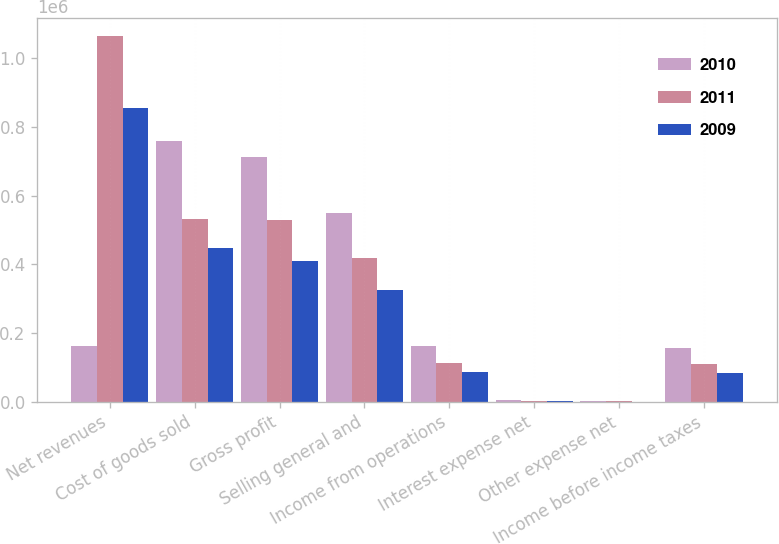<chart> <loc_0><loc_0><loc_500><loc_500><stacked_bar_chart><ecel><fcel>Net revenues<fcel>Cost of goods sold<fcel>Gross profit<fcel>Selling general and<fcel>Income from operations<fcel>Interest expense net<fcel>Other expense net<fcel>Income before income taxes<nl><fcel>2010<fcel>162767<fcel>759848<fcel>712836<fcel>550069<fcel>162767<fcel>3841<fcel>2064<fcel>156862<nl><fcel>2011<fcel>1.06393e+06<fcel>533420<fcel>530507<fcel>418152<fcel>112355<fcel>2258<fcel>1178<fcel>108919<nl><fcel>2009<fcel>856411<fcel>446286<fcel>410125<fcel>324852<fcel>85273<fcel>2344<fcel>511<fcel>82418<nl></chart> 